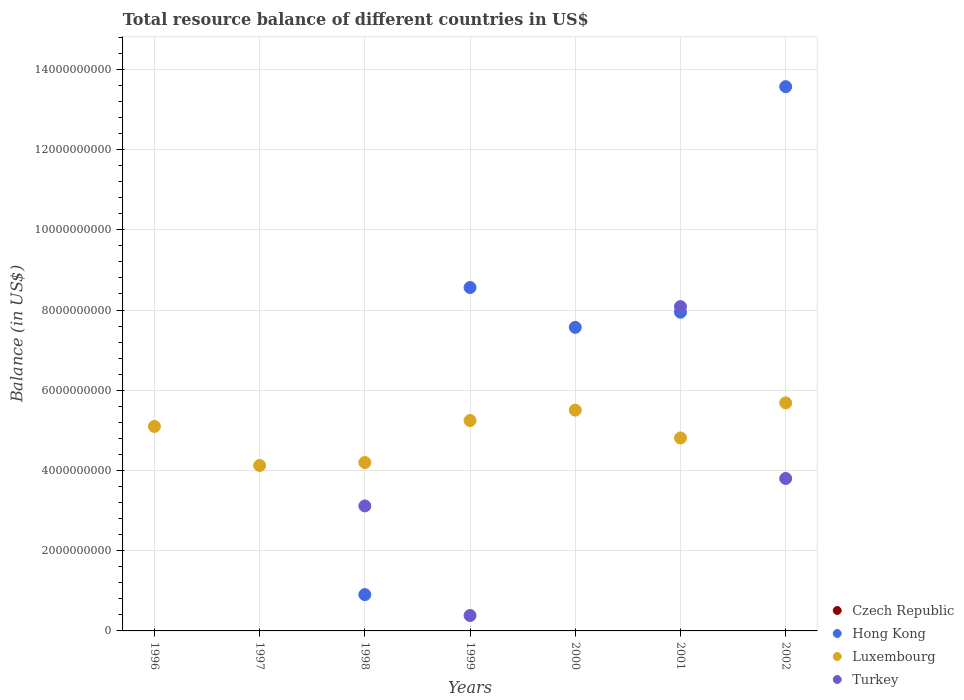How many different coloured dotlines are there?
Provide a short and direct response. 3. What is the total resource balance in Turkey in 2002?
Ensure brevity in your answer.  3.80e+09. Across all years, what is the maximum total resource balance in Turkey?
Offer a very short reply. 8.09e+09. Across all years, what is the minimum total resource balance in Hong Kong?
Keep it short and to the point. 0. In which year was the total resource balance in Luxembourg maximum?
Your answer should be compact. 2002. What is the total total resource balance in Hong Kong in the graph?
Your answer should be compact. 3.86e+1. What is the difference between the total resource balance in Hong Kong in 1998 and that in 2002?
Offer a terse response. -1.27e+1. What is the difference between the total resource balance in Czech Republic in 2002 and the total resource balance in Luxembourg in 1999?
Your answer should be compact. -5.25e+09. What is the average total resource balance in Turkey per year?
Ensure brevity in your answer.  2.20e+09. In the year 1998, what is the difference between the total resource balance in Turkey and total resource balance in Hong Kong?
Your answer should be very brief. 2.21e+09. What is the ratio of the total resource balance in Luxembourg in 1998 to that in 2002?
Your response must be concise. 0.74. Is the difference between the total resource balance in Turkey in 1998 and 1999 greater than the difference between the total resource balance in Hong Kong in 1998 and 1999?
Your answer should be compact. Yes. What is the difference between the highest and the second highest total resource balance in Hong Kong?
Provide a succinct answer. 5.01e+09. What is the difference between the highest and the lowest total resource balance in Hong Kong?
Give a very brief answer. 1.36e+1. Does the total resource balance in Hong Kong monotonically increase over the years?
Keep it short and to the point. No. Is the total resource balance in Czech Republic strictly greater than the total resource balance in Turkey over the years?
Make the answer very short. No. Is the total resource balance in Czech Republic strictly less than the total resource balance in Hong Kong over the years?
Your answer should be compact. No. How many dotlines are there?
Provide a succinct answer. 3. How many years are there in the graph?
Provide a short and direct response. 7. What is the difference between two consecutive major ticks on the Y-axis?
Keep it short and to the point. 2.00e+09. Are the values on the major ticks of Y-axis written in scientific E-notation?
Offer a very short reply. No. Does the graph contain any zero values?
Your response must be concise. Yes. Where does the legend appear in the graph?
Your response must be concise. Bottom right. How many legend labels are there?
Your answer should be very brief. 4. How are the legend labels stacked?
Provide a succinct answer. Vertical. What is the title of the graph?
Give a very brief answer. Total resource balance of different countries in US$. Does "Guinea-Bissau" appear as one of the legend labels in the graph?
Provide a succinct answer. No. What is the label or title of the Y-axis?
Offer a terse response. Balance (in US$). What is the Balance (in US$) of Luxembourg in 1996?
Ensure brevity in your answer.  5.10e+09. What is the Balance (in US$) of Turkey in 1996?
Offer a terse response. 0. What is the Balance (in US$) in Hong Kong in 1997?
Give a very brief answer. 0. What is the Balance (in US$) of Luxembourg in 1997?
Offer a very short reply. 4.12e+09. What is the Balance (in US$) in Czech Republic in 1998?
Provide a succinct answer. 0. What is the Balance (in US$) of Hong Kong in 1998?
Offer a terse response. 9.05e+08. What is the Balance (in US$) in Luxembourg in 1998?
Ensure brevity in your answer.  4.20e+09. What is the Balance (in US$) of Turkey in 1998?
Keep it short and to the point. 3.12e+09. What is the Balance (in US$) of Czech Republic in 1999?
Offer a terse response. 0. What is the Balance (in US$) in Hong Kong in 1999?
Keep it short and to the point. 8.56e+09. What is the Balance (in US$) in Luxembourg in 1999?
Keep it short and to the point. 5.25e+09. What is the Balance (in US$) in Turkey in 1999?
Keep it short and to the point. 3.84e+08. What is the Balance (in US$) of Czech Republic in 2000?
Make the answer very short. 0. What is the Balance (in US$) in Hong Kong in 2000?
Make the answer very short. 7.57e+09. What is the Balance (in US$) in Luxembourg in 2000?
Ensure brevity in your answer.  5.50e+09. What is the Balance (in US$) in Czech Republic in 2001?
Provide a succinct answer. 0. What is the Balance (in US$) in Hong Kong in 2001?
Provide a short and direct response. 7.95e+09. What is the Balance (in US$) of Luxembourg in 2001?
Provide a short and direct response. 4.81e+09. What is the Balance (in US$) in Turkey in 2001?
Offer a terse response. 8.09e+09. What is the Balance (in US$) of Czech Republic in 2002?
Keep it short and to the point. 0. What is the Balance (in US$) in Hong Kong in 2002?
Offer a terse response. 1.36e+1. What is the Balance (in US$) of Luxembourg in 2002?
Ensure brevity in your answer.  5.69e+09. What is the Balance (in US$) in Turkey in 2002?
Provide a short and direct response. 3.80e+09. Across all years, what is the maximum Balance (in US$) in Hong Kong?
Make the answer very short. 1.36e+1. Across all years, what is the maximum Balance (in US$) in Luxembourg?
Your answer should be very brief. 5.69e+09. Across all years, what is the maximum Balance (in US$) in Turkey?
Provide a succinct answer. 8.09e+09. Across all years, what is the minimum Balance (in US$) of Luxembourg?
Provide a succinct answer. 4.12e+09. Across all years, what is the minimum Balance (in US$) in Turkey?
Keep it short and to the point. 0. What is the total Balance (in US$) of Hong Kong in the graph?
Give a very brief answer. 3.86e+1. What is the total Balance (in US$) in Luxembourg in the graph?
Provide a succinct answer. 3.47e+1. What is the total Balance (in US$) of Turkey in the graph?
Ensure brevity in your answer.  1.54e+1. What is the difference between the Balance (in US$) in Luxembourg in 1996 and that in 1997?
Keep it short and to the point. 9.73e+08. What is the difference between the Balance (in US$) in Luxembourg in 1996 and that in 1998?
Offer a terse response. 8.99e+08. What is the difference between the Balance (in US$) in Luxembourg in 1996 and that in 1999?
Make the answer very short. -1.48e+08. What is the difference between the Balance (in US$) of Luxembourg in 1996 and that in 2000?
Provide a short and direct response. -4.07e+08. What is the difference between the Balance (in US$) of Luxembourg in 1996 and that in 2001?
Make the answer very short. 2.87e+08. What is the difference between the Balance (in US$) of Luxembourg in 1996 and that in 2002?
Give a very brief answer. -5.88e+08. What is the difference between the Balance (in US$) in Luxembourg in 1997 and that in 1998?
Your answer should be compact. -7.42e+07. What is the difference between the Balance (in US$) in Luxembourg in 1997 and that in 1999?
Provide a succinct answer. -1.12e+09. What is the difference between the Balance (in US$) of Luxembourg in 1997 and that in 2000?
Offer a terse response. -1.38e+09. What is the difference between the Balance (in US$) of Luxembourg in 1997 and that in 2001?
Offer a terse response. -6.86e+08. What is the difference between the Balance (in US$) of Luxembourg in 1997 and that in 2002?
Ensure brevity in your answer.  -1.56e+09. What is the difference between the Balance (in US$) of Hong Kong in 1998 and that in 1999?
Make the answer very short. -7.66e+09. What is the difference between the Balance (in US$) in Luxembourg in 1998 and that in 1999?
Make the answer very short. -1.05e+09. What is the difference between the Balance (in US$) of Turkey in 1998 and that in 1999?
Keep it short and to the point. 2.73e+09. What is the difference between the Balance (in US$) in Hong Kong in 1998 and that in 2000?
Your answer should be compact. -6.66e+09. What is the difference between the Balance (in US$) in Luxembourg in 1998 and that in 2000?
Your response must be concise. -1.31e+09. What is the difference between the Balance (in US$) in Hong Kong in 1998 and that in 2001?
Ensure brevity in your answer.  -7.04e+09. What is the difference between the Balance (in US$) of Luxembourg in 1998 and that in 2001?
Provide a short and direct response. -6.12e+08. What is the difference between the Balance (in US$) in Turkey in 1998 and that in 2001?
Make the answer very short. -4.97e+09. What is the difference between the Balance (in US$) in Hong Kong in 1998 and that in 2002?
Your response must be concise. -1.27e+1. What is the difference between the Balance (in US$) of Luxembourg in 1998 and that in 2002?
Offer a terse response. -1.49e+09. What is the difference between the Balance (in US$) in Turkey in 1998 and that in 2002?
Your response must be concise. -6.84e+08. What is the difference between the Balance (in US$) in Hong Kong in 1999 and that in 2000?
Provide a succinct answer. 9.93e+08. What is the difference between the Balance (in US$) of Luxembourg in 1999 and that in 2000?
Keep it short and to the point. -2.59e+08. What is the difference between the Balance (in US$) of Hong Kong in 1999 and that in 2001?
Ensure brevity in your answer.  6.16e+08. What is the difference between the Balance (in US$) of Luxembourg in 1999 and that in 2001?
Give a very brief answer. 4.35e+08. What is the difference between the Balance (in US$) of Turkey in 1999 and that in 2001?
Your response must be concise. -7.70e+09. What is the difference between the Balance (in US$) in Hong Kong in 1999 and that in 2002?
Provide a short and direct response. -5.01e+09. What is the difference between the Balance (in US$) of Luxembourg in 1999 and that in 2002?
Offer a very short reply. -4.41e+08. What is the difference between the Balance (in US$) of Turkey in 1999 and that in 2002?
Provide a short and direct response. -3.42e+09. What is the difference between the Balance (in US$) of Hong Kong in 2000 and that in 2001?
Offer a terse response. -3.77e+08. What is the difference between the Balance (in US$) of Luxembourg in 2000 and that in 2001?
Your answer should be very brief. 6.94e+08. What is the difference between the Balance (in US$) of Hong Kong in 2000 and that in 2002?
Your answer should be compact. -6.00e+09. What is the difference between the Balance (in US$) in Luxembourg in 2000 and that in 2002?
Your response must be concise. -1.81e+08. What is the difference between the Balance (in US$) in Hong Kong in 2001 and that in 2002?
Provide a short and direct response. -5.62e+09. What is the difference between the Balance (in US$) of Luxembourg in 2001 and that in 2002?
Provide a short and direct response. -8.75e+08. What is the difference between the Balance (in US$) in Turkey in 2001 and that in 2002?
Give a very brief answer. 4.29e+09. What is the difference between the Balance (in US$) in Luxembourg in 1996 and the Balance (in US$) in Turkey in 1998?
Make the answer very short. 1.98e+09. What is the difference between the Balance (in US$) in Luxembourg in 1996 and the Balance (in US$) in Turkey in 1999?
Your answer should be very brief. 4.71e+09. What is the difference between the Balance (in US$) of Luxembourg in 1996 and the Balance (in US$) of Turkey in 2001?
Your response must be concise. -2.99e+09. What is the difference between the Balance (in US$) in Luxembourg in 1996 and the Balance (in US$) in Turkey in 2002?
Your answer should be compact. 1.30e+09. What is the difference between the Balance (in US$) in Luxembourg in 1997 and the Balance (in US$) in Turkey in 1998?
Give a very brief answer. 1.01e+09. What is the difference between the Balance (in US$) of Luxembourg in 1997 and the Balance (in US$) of Turkey in 1999?
Offer a terse response. 3.74e+09. What is the difference between the Balance (in US$) of Luxembourg in 1997 and the Balance (in US$) of Turkey in 2001?
Your answer should be very brief. -3.96e+09. What is the difference between the Balance (in US$) in Luxembourg in 1997 and the Balance (in US$) in Turkey in 2002?
Offer a terse response. 3.24e+08. What is the difference between the Balance (in US$) in Hong Kong in 1998 and the Balance (in US$) in Luxembourg in 1999?
Your response must be concise. -4.34e+09. What is the difference between the Balance (in US$) in Hong Kong in 1998 and the Balance (in US$) in Turkey in 1999?
Keep it short and to the point. 5.21e+08. What is the difference between the Balance (in US$) of Luxembourg in 1998 and the Balance (in US$) of Turkey in 1999?
Offer a terse response. 3.81e+09. What is the difference between the Balance (in US$) in Hong Kong in 1998 and the Balance (in US$) in Luxembourg in 2000?
Provide a short and direct response. -4.60e+09. What is the difference between the Balance (in US$) of Hong Kong in 1998 and the Balance (in US$) of Luxembourg in 2001?
Make the answer very short. -3.91e+09. What is the difference between the Balance (in US$) in Hong Kong in 1998 and the Balance (in US$) in Turkey in 2001?
Your response must be concise. -7.18e+09. What is the difference between the Balance (in US$) in Luxembourg in 1998 and the Balance (in US$) in Turkey in 2001?
Provide a short and direct response. -3.89e+09. What is the difference between the Balance (in US$) of Hong Kong in 1998 and the Balance (in US$) of Luxembourg in 2002?
Provide a short and direct response. -4.78e+09. What is the difference between the Balance (in US$) of Hong Kong in 1998 and the Balance (in US$) of Turkey in 2002?
Your answer should be compact. -2.90e+09. What is the difference between the Balance (in US$) in Luxembourg in 1998 and the Balance (in US$) in Turkey in 2002?
Your answer should be compact. 3.98e+08. What is the difference between the Balance (in US$) in Hong Kong in 1999 and the Balance (in US$) in Luxembourg in 2000?
Provide a short and direct response. 3.06e+09. What is the difference between the Balance (in US$) in Hong Kong in 1999 and the Balance (in US$) in Luxembourg in 2001?
Offer a terse response. 3.75e+09. What is the difference between the Balance (in US$) of Hong Kong in 1999 and the Balance (in US$) of Turkey in 2001?
Provide a short and direct response. 4.75e+08. What is the difference between the Balance (in US$) of Luxembourg in 1999 and the Balance (in US$) of Turkey in 2001?
Provide a succinct answer. -2.84e+09. What is the difference between the Balance (in US$) of Hong Kong in 1999 and the Balance (in US$) of Luxembourg in 2002?
Offer a very short reply. 2.88e+09. What is the difference between the Balance (in US$) of Hong Kong in 1999 and the Balance (in US$) of Turkey in 2002?
Your response must be concise. 4.76e+09. What is the difference between the Balance (in US$) in Luxembourg in 1999 and the Balance (in US$) in Turkey in 2002?
Make the answer very short. 1.44e+09. What is the difference between the Balance (in US$) of Hong Kong in 2000 and the Balance (in US$) of Luxembourg in 2001?
Provide a succinct answer. 2.76e+09. What is the difference between the Balance (in US$) in Hong Kong in 2000 and the Balance (in US$) in Turkey in 2001?
Provide a succinct answer. -5.18e+08. What is the difference between the Balance (in US$) of Luxembourg in 2000 and the Balance (in US$) of Turkey in 2001?
Your response must be concise. -2.58e+09. What is the difference between the Balance (in US$) in Hong Kong in 2000 and the Balance (in US$) in Luxembourg in 2002?
Keep it short and to the point. 1.88e+09. What is the difference between the Balance (in US$) in Hong Kong in 2000 and the Balance (in US$) in Turkey in 2002?
Make the answer very short. 3.77e+09. What is the difference between the Balance (in US$) in Luxembourg in 2000 and the Balance (in US$) in Turkey in 2002?
Provide a short and direct response. 1.70e+09. What is the difference between the Balance (in US$) in Hong Kong in 2001 and the Balance (in US$) in Luxembourg in 2002?
Your response must be concise. 2.26e+09. What is the difference between the Balance (in US$) of Hong Kong in 2001 and the Balance (in US$) of Turkey in 2002?
Your answer should be very brief. 4.14e+09. What is the difference between the Balance (in US$) of Luxembourg in 2001 and the Balance (in US$) of Turkey in 2002?
Ensure brevity in your answer.  1.01e+09. What is the average Balance (in US$) of Czech Republic per year?
Your response must be concise. 0. What is the average Balance (in US$) of Hong Kong per year?
Provide a succinct answer. 5.51e+09. What is the average Balance (in US$) in Luxembourg per year?
Your response must be concise. 4.95e+09. What is the average Balance (in US$) in Turkey per year?
Offer a terse response. 2.20e+09. In the year 1998, what is the difference between the Balance (in US$) in Hong Kong and Balance (in US$) in Luxembourg?
Keep it short and to the point. -3.29e+09. In the year 1998, what is the difference between the Balance (in US$) in Hong Kong and Balance (in US$) in Turkey?
Provide a succinct answer. -2.21e+09. In the year 1998, what is the difference between the Balance (in US$) of Luxembourg and Balance (in US$) of Turkey?
Ensure brevity in your answer.  1.08e+09. In the year 1999, what is the difference between the Balance (in US$) of Hong Kong and Balance (in US$) of Luxembourg?
Your answer should be compact. 3.32e+09. In the year 1999, what is the difference between the Balance (in US$) of Hong Kong and Balance (in US$) of Turkey?
Give a very brief answer. 8.18e+09. In the year 1999, what is the difference between the Balance (in US$) of Luxembourg and Balance (in US$) of Turkey?
Give a very brief answer. 4.86e+09. In the year 2000, what is the difference between the Balance (in US$) of Hong Kong and Balance (in US$) of Luxembourg?
Provide a succinct answer. 2.06e+09. In the year 2001, what is the difference between the Balance (in US$) of Hong Kong and Balance (in US$) of Luxembourg?
Offer a very short reply. 3.13e+09. In the year 2001, what is the difference between the Balance (in US$) in Hong Kong and Balance (in US$) in Turkey?
Ensure brevity in your answer.  -1.41e+08. In the year 2001, what is the difference between the Balance (in US$) of Luxembourg and Balance (in US$) of Turkey?
Give a very brief answer. -3.28e+09. In the year 2002, what is the difference between the Balance (in US$) of Hong Kong and Balance (in US$) of Luxembourg?
Make the answer very short. 7.88e+09. In the year 2002, what is the difference between the Balance (in US$) of Hong Kong and Balance (in US$) of Turkey?
Your answer should be compact. 9.77e+09. In the year 2002, what is the difference between the Balance (in US$) of Luxembourg and Balance (in US$) of Turkey?
Provide a short and direct response. 1.89e+09. What is the ratio of the Balance (in US$) of Luxembourg in 1996 to that in 1997?
Provide a succinct answer. 1.24. What is the ratio of the Balance (in US$) in Luxembourg in 1996 to that in 1998?
Provide a short and direct response. 1.21. What is the ratio of the Balance (in US$) of Luxembourg in 1996 to that in 1999?
Give a very brief answer. 0.97. What is the ratio of the Balance (in US$) in Luxembourg in 1996 to that in 2000?
Your answer should be very brief. 0.93. What is the ratio of the Balance (in US$) of Luxembourg in 1996 to that in 2001?
Ensure brevity in your answer.  1.06. What is the ratio of the Balance (in US$) of Luxembourg in 1996 to that in 2002?
Your answer should be compact. 0.9. What is the ratio of the Balance (in US$) in Luxembourg in 1997 to that in 1998?
Ensure brevity in your answer.  0.98. What is the ratio of the Balance (in US$) in Luxembourg in 1997 to that in 1999?
Give a very brief answer. 0.79. What is the ratio of the Balance (in US$) in Luxembourg in 1997 to that in 2000?
Make the answer very short. 0.75. What is the ratio of the Balance (in US$) in Luxembourg in 1997 to that in 2001?
Make the answer very short. 0.86. What is the ratio of the Balance (in US$) in Luxembourg in 1997 to that in 2002?
Your response must be concise. 0.73. What is the ratio of the Balance (in US$) in Hong Kong in 1998 to that in 1999?
Provide a short and direct response. 0.11. What is the ratio of the Balance (in US$) of Luxembourg in 1998 to that in 1999?
Your response must be concise. 0.8. What is the ratio of the Balance (in US$) in Turkey in 1998 to that in 1999?
Offer a terse response. 8.11. What is the ratio of the Balance (in US$) in Hong Kong in 1998 to that in 2000?
Offer a very short reply. 0.12. What is the ratio of the Balance (in US$) in Luxembourg in 1998 to that in 2000?
Offer a terse response. 0.76. What is the ratio of the Balance (in US$) in Hong Kong in 1998 to that in 2001?
Give a very brief answer. 0.11. What is the ratio of the Balance (in US$) in Luxembourg in 1998 to that in 2001?
Offer a very short reply. 0.87. What is the ratio of the Balance (in US$) in Turkey in 1998 to that in 2001?
Make the answer very short. 0.39. What is the ratio of the Balance (in US$) of Hong Kong in 1998 to that in 2002?
Your answer should be very brief. 0.07. What is the ratio of the Balance (in US$) in Luxembourg in 1998 to that in 2002?
Your answer should be compact. 0.74. What is the ratio of the Balance (in US$) of Turkey in 1998 to that in 2002?
Provide a succinct answer. 0.82. What is the ratio of the Balance (in US$) of Hong Kong in 1999 to that in 2000?
Provide a short and direct response. 1.13. What is the ratio of the Balance (in US$) in Luxembourg in 1999 to that in 2000?
Provide a short and direct response. 0.95. What is the ratio of the Balance (in US$) of Hong Kong in 1999 to that in 2001?
Keep it short and to the point. 1.08. What is the ratio of the Balance (in US$) in Luxembourg in 1999 to that in 2001?
Give a very brief answer. 1.09. What is the ratio of the Balance (in US$) of Turkey in 1999 to that in 2001?
Offer a terse response. 0.05. What is the ratio of the Balance (in US$) in Hong Kong in 1999 to that in 2002?
Provide a short and direct response. 0.63. What is the ratio of the Balance (in US$) of Luxembourg in 1999 to that in 2002?
Your answer should be compact. 0.92. What is the ratio of the Balance (in US$) in Turkey in 1999 to that in 2002?
Your answer should be compact. 0.1. What is the ratio of the Balance (in US$) of Hong Kong in 2000 to that in 2001?
Give a very brief answer. 0.95. What is the ratio of the Balance (in US$) of Luxembourg in 2000 to that in 2001?
Ensure brevity in your answer.  1.14. What is the ratio of the Balance (in US$) in Hong Kong in 2000 to that in 2002?
Your answer should be very brief. 0.56. What is the ratio of the Balance (in US$) of Luxembourg in 2000 to that in 2002?
Offer a terse response. 0.97. What is the ratio of the Balance (in US$) of Hong Kong in 2001 to that in 2002?
Your answer should be very brief. 0.59. What is the ratio of the Balance (in US$) in Luxembourg in 2001 to that in 2002?
Offer a terse response. 0.85. What is the ratio of the Balance (in US$) in Turkey in 2001 to that in 2002?
Your answer should be very brief. 2.13. What is the difference between the highest and the second highest Balance (in US$) of Hong Kong?
Provide a short and direct response. 5.01e+09. What is the difference between the highest and the second highest Balance (in US$) of Luxembourg?
Your answer should be compact. 1.81e+08. What is the difference between the highest and the second highest Balance (in US$) of Turkey?
Offer a terse response. 4.29e+09. What is the difference between the highest and the lowest Balance (in US$) in Hong Kong?
Make the answer very short. 1.36e+1. What is the difference between the highest and the lowest Balance (in US$) of Luxembourg?
Your response must be concise. 1.56e+09. What is the difference between the highest and the lowest Balance (in US$) in Turkey?
Give a very brief answer. 8.09e+09. 